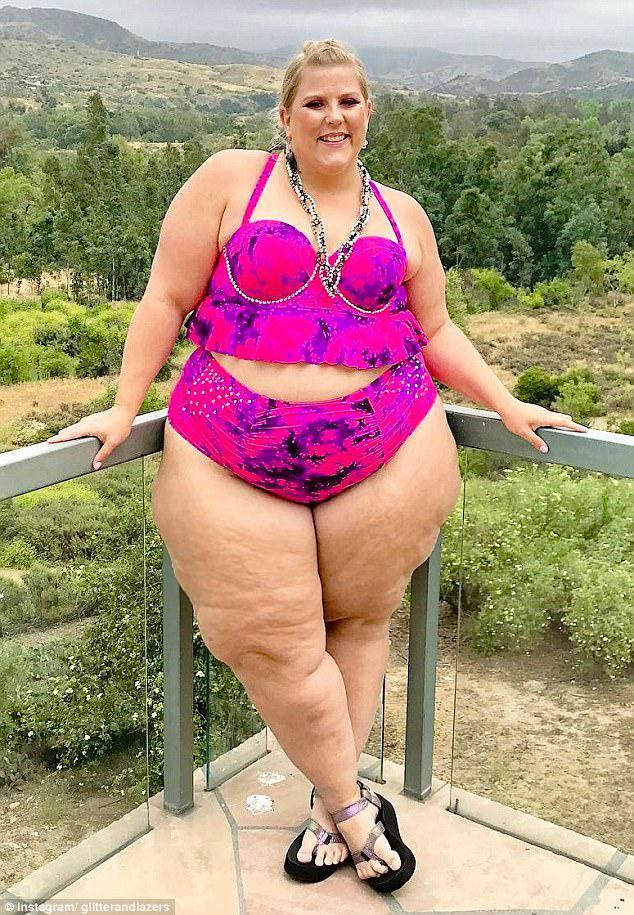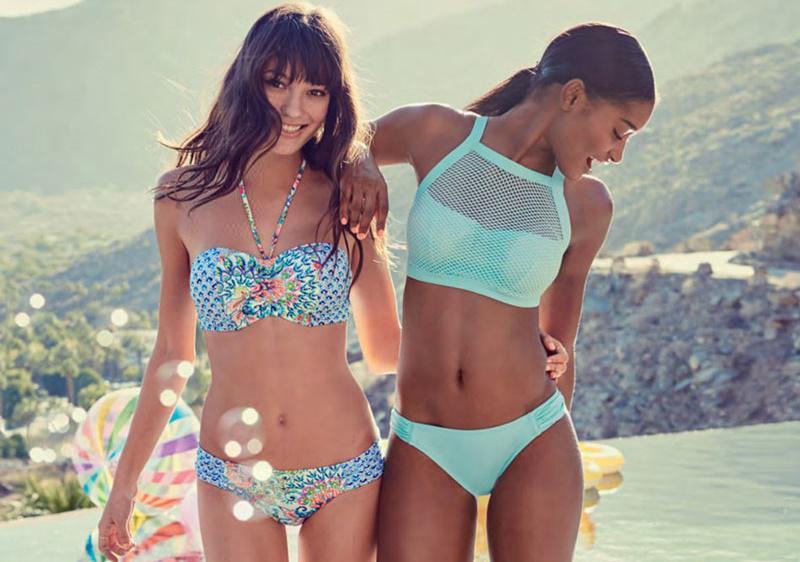The first image is the image on the left, the second image is the image on the right. Assess this claim about the two images: "One image contains exactly three bikini models, and the other image contains no more than two bikini models and includes a blue bikini bottom and an orange bikini top.". Correct or not? Answer yes or no. No. The first image is the image on the left, the second image is the image on the right. For the images displayed, is the sentence "One of the images contains exactly two women in swimsuits." factually correct? Answer yes or no. Yes. 